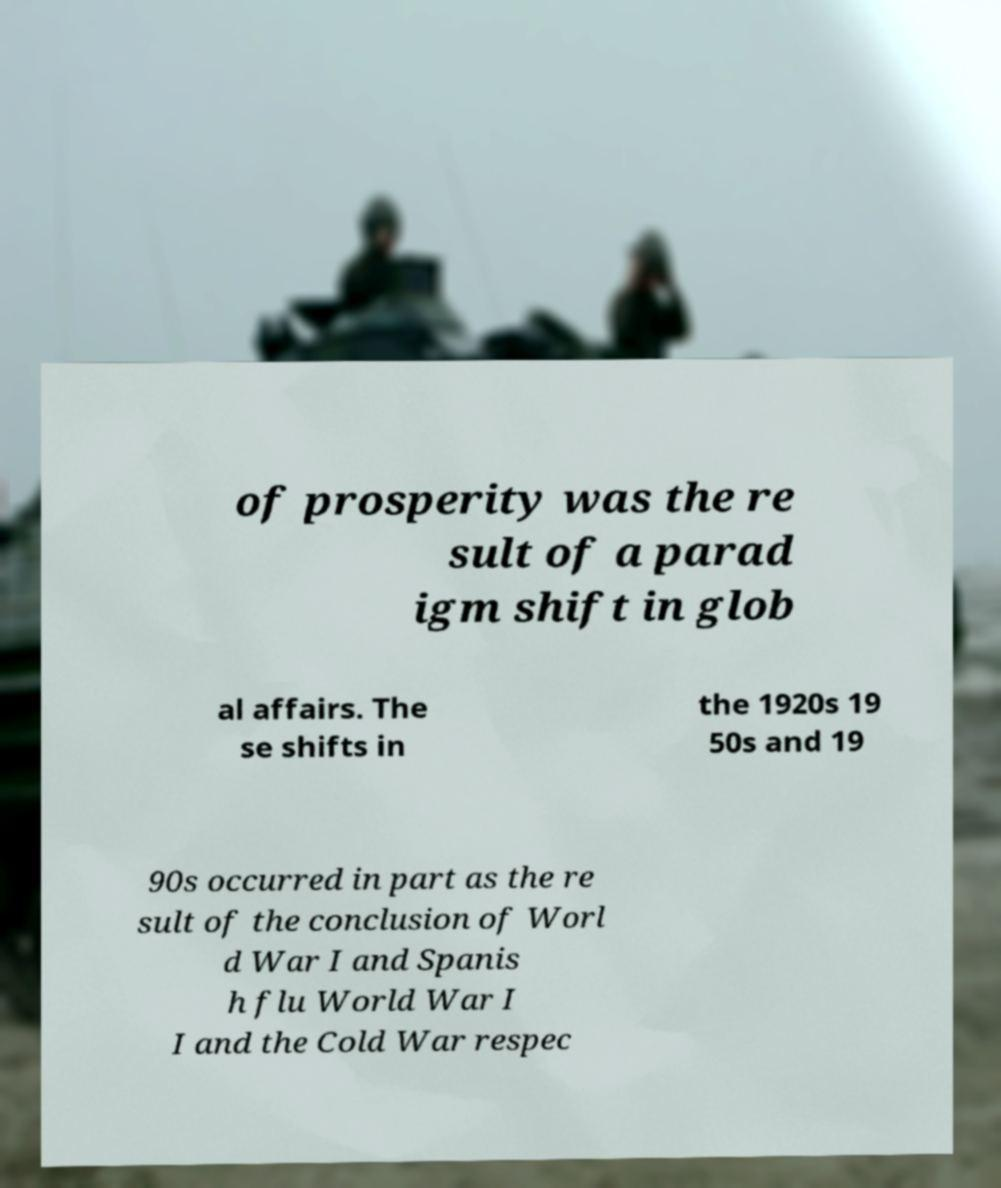I need the written content from this picture converted into text. Can you do that? of prosperity was the re sult of a parad igm shift in glob al affairs. The se shifts in the 1920s 19 50s and 19 90s occurred in part as the re sult of the conclusion of Worl d War I and Spanis h flu World War I I and the Cold War respec 